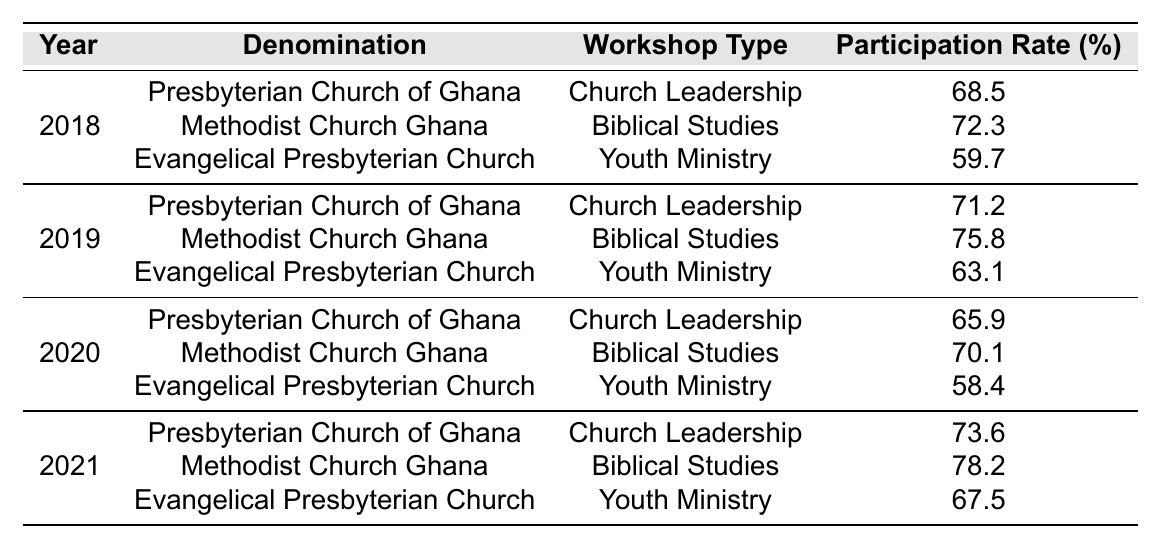What was the participation rate for the Methodist Church Ghana in 2021 for Biblical Studies? In the table, I find the row for the year 2021 and the denomination 'Methodist Church Ghana' under the 'Biblical Studies' workshop type, which shows a participation rate of 78.2%.
Answer: 78.2% Which year had the highest participation rate for Evangelical Presbyterian Church in Youth Ministry? Looking at the rows for Evangelical Presbyterian Church and Youth Ministry, the participation rates are 59.7% for 2018, 63.1% for 2019, 58.4% for 2020, and 67.5% for 2021. The year with the highest participation rate is 2021 at 67.5%.
Answer: 2021 What is the average participation rate for the Presbyterian Church of Ghana from 2018 to 2021? The participation rates for the Presbyterian Church of Ghana are 68.5% (2018), 71.2% (2019), 65.9% (2020), and 73.6% (2021). Adding these gives 68.5 + 71.2 + 65.9 + 73.6 = 279.2. Dividing by 4 (the number of years) results in an average of 69.8%.
Answer: 69.8% Did the participation rate for the Methodist Church Ghana in Biblical Studies increase every year from 2018 to 2021? Checking the participation rates: in 2018 it was 72.3%, in 2019 it increased to 75.8%, in 2020 it was 70.1% (a decrease), and in 2021 it rose again to 78.2%. Since there was a decrease in 2020, the answer is no.
Answer: No What was the highest participation rate in 2020 among the three denominations? In 2020, the participation rates were 65.9% for the Presbyterian Church of Ghana, 70.1% for the Methodist Church Ghana, and 58.4% for the Evangelical Presbyterian Church. The highest participation rate is 70.1% for the Methodist Church Ghana.
Answer: 70.1% Calculate the difference in participation rates for the Presbyterian Church of Ghana between 2018 and 2021. The participation rates for the Presbyterian Church of Ghana are 68.5% in 2018 and 73.6% in 2021. The difference is 73.6% - 68.5% = 5.1%.
Answer: 5.1% Which workshop type had the lowest overall participation rate in 2018? Analyzing the 2018 participation rates, the Presbyterian Church of Ghana in Church Leadership had 68.5%, the Methodist Church Ghana in Biblical Studies had 72.3%, and the Evangelical Presbyterian Church in Youth Ministry had 59.7%. The lowest rate was 59.7% for the Youth Ministry.
Answer: Youth Ministry Was the participation rate for any workshop type in 2019 greater than 75%? In 2019, the Methodist Church Ghana in Biblical Studies had a participation rate of 75.8%. Since this is greater than 75%, the answer is yes.
Answer: Yes What was the trend in participation rates for Evangelical Presbyterian Church in Youth Ministry from 2018 to 2021? The participation rates for Evangelical Presbyterian Church in Youth Ministry were 59.7% (2018), 63.1% (2019), 58.4% (2020), and 67.5% (2021). The trend shows an increase from 2018 to 2019, a decrease in 2020, and an increase again in 2021.
Answer: Mixed (increased, decreased, increased) Who had a higher participation rate in 2020, the Presbyterian Church of Ghana or the Evangelical Presbyterian Church? In 2020, the Presbyterian Church of Ghana had a participation rate of 65.9%, while the Evangelical Presbyterian Church had 58.4%. Therefore, the Presbyterian Church of Ghana had the higher rate.
Answer: Presbyterian Church of Ghana 